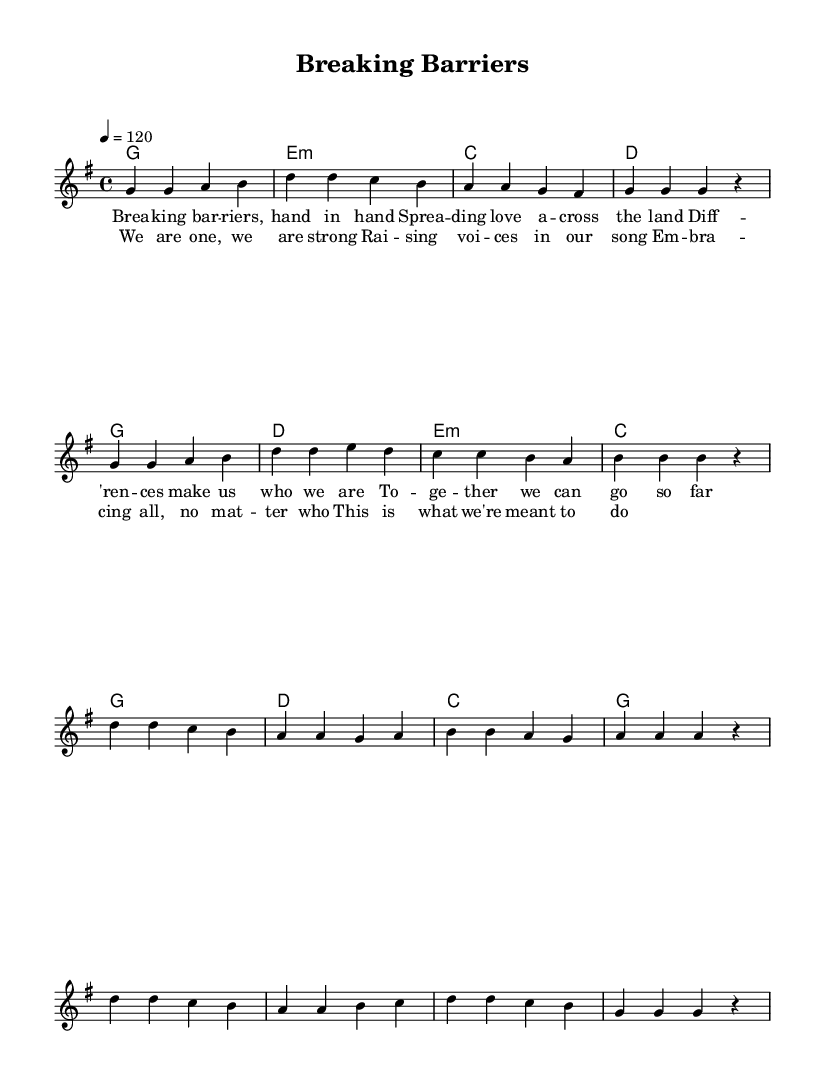What is the key signature of this music? The key signature indicates the notes that are sharp or flat in the piece. In this score, it is marked as G major, which has one sharp (F#).
Answer: G major What is the time signature of this piece? The time signature defines how many beats are in each measure. This score shows a 4/4 time signature, meaning there are four beats per measure.
Answer: 4/4 What is the tempo marking of the music? The tempo indicates how fast the music should be played. In the score, it is marked as 120 beats per minute, which is indicated clear as "4 = 120".
Answer: 120 What is the introductory theme of the lyrics? By analyzing the lyrics provided, the introductory theme emphasizes unity and overcoming differences. The lyrics describe breaking barriers and spreading love.
Answer: Unity and inclusivity How many chords are used in the chorus? The chord changes in the chorus indicate how many unique chords are played. By examining the chord mode in the score, there are 5 unique chords in the chorus.
Answer: 5 What is the overall message conveyed in the lyrics? The overall message in the lyrics highlights embracing diversity and unity among people. It expresses a strong belief in collective strength and inclusivity.
Answer: Embrace diversity 